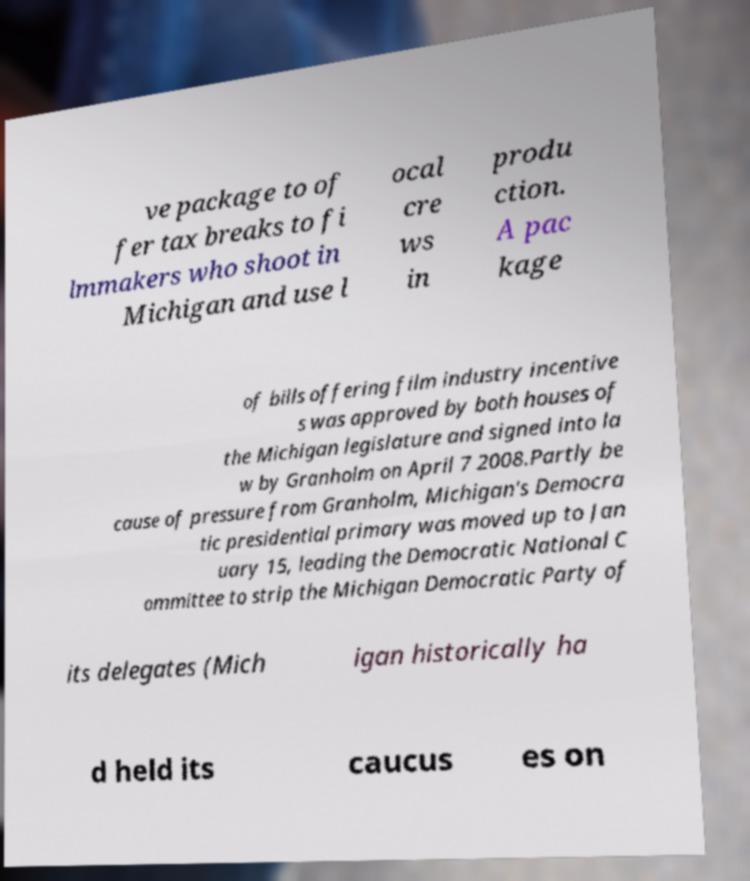What messages or text are displayed in this image? I need them in a readable, typed format. ve package to of fer tax breaks to fi lmmakers who shoot in Michigan and use l ocal cre ws in produ ction. A pac kage of bills offering film industry incentive s was approved by both houses of the Michigan legislature and signed into la w by Granholm on April 7 2008.Partly be cause of pressure from Granholm, Michigan's Democra tic presidential primary was moved up to Jan uary 15, leading the Democratic National C ommittee to strip the Michigan Democratic Party of its delegates (Mich igan historically ha d held its caucus es on 